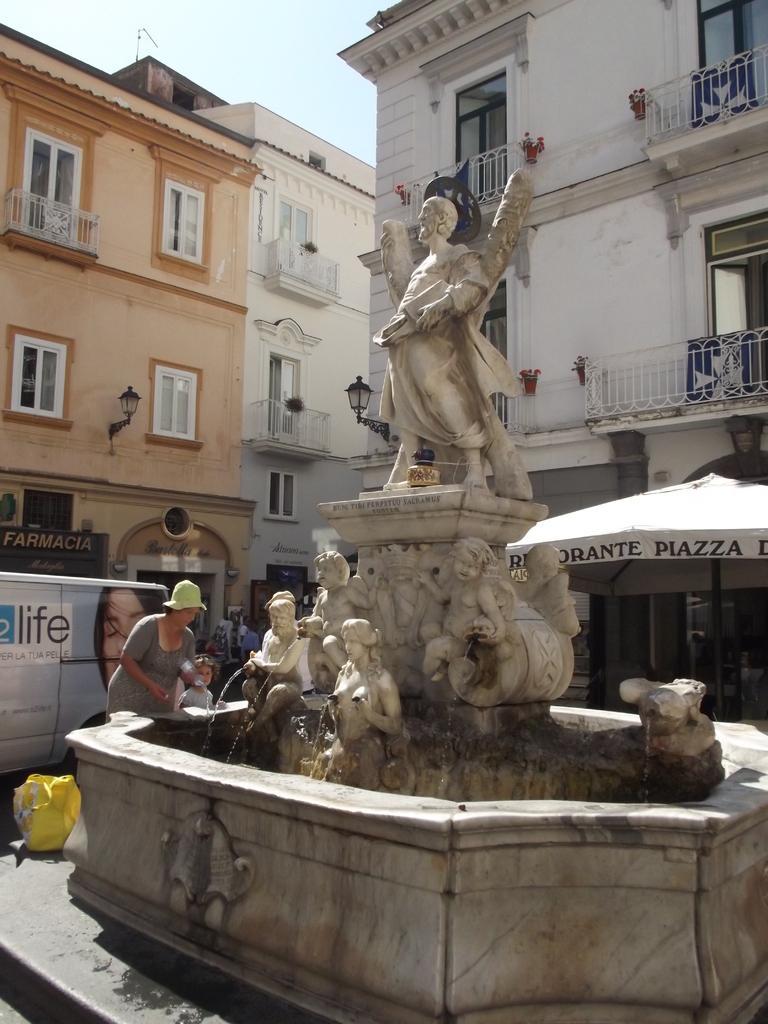How would you summarize this image in a sentence or two? In this image I can see few statues in cream color and I can also see the person standing. In the background I can see few stalls and I can also see few buildings in white and brown color and the sky is in white color. 